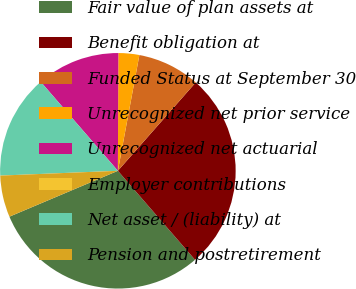<chart> <loc_0><loc_0><loc_500><loc_500><pie_chart><fcel>Fair value of plan assets at<fcel>Benefit obligation at<fcel>Funded Status at September 30<fcel>Unrecognized net prior service<fcel>Unrecognized net actuarial<fcel>Employer contributions<fcel>Net asset / (liability) at<fcel>Pension and postretirement<nl><fcel>30.0%<fcel>27.14%<fcel>8.57%<fcel>2.86%<fcel>11.43%<fcel>0.0%<fcel>14.28%<fcel>5.72%<nl></chart> 